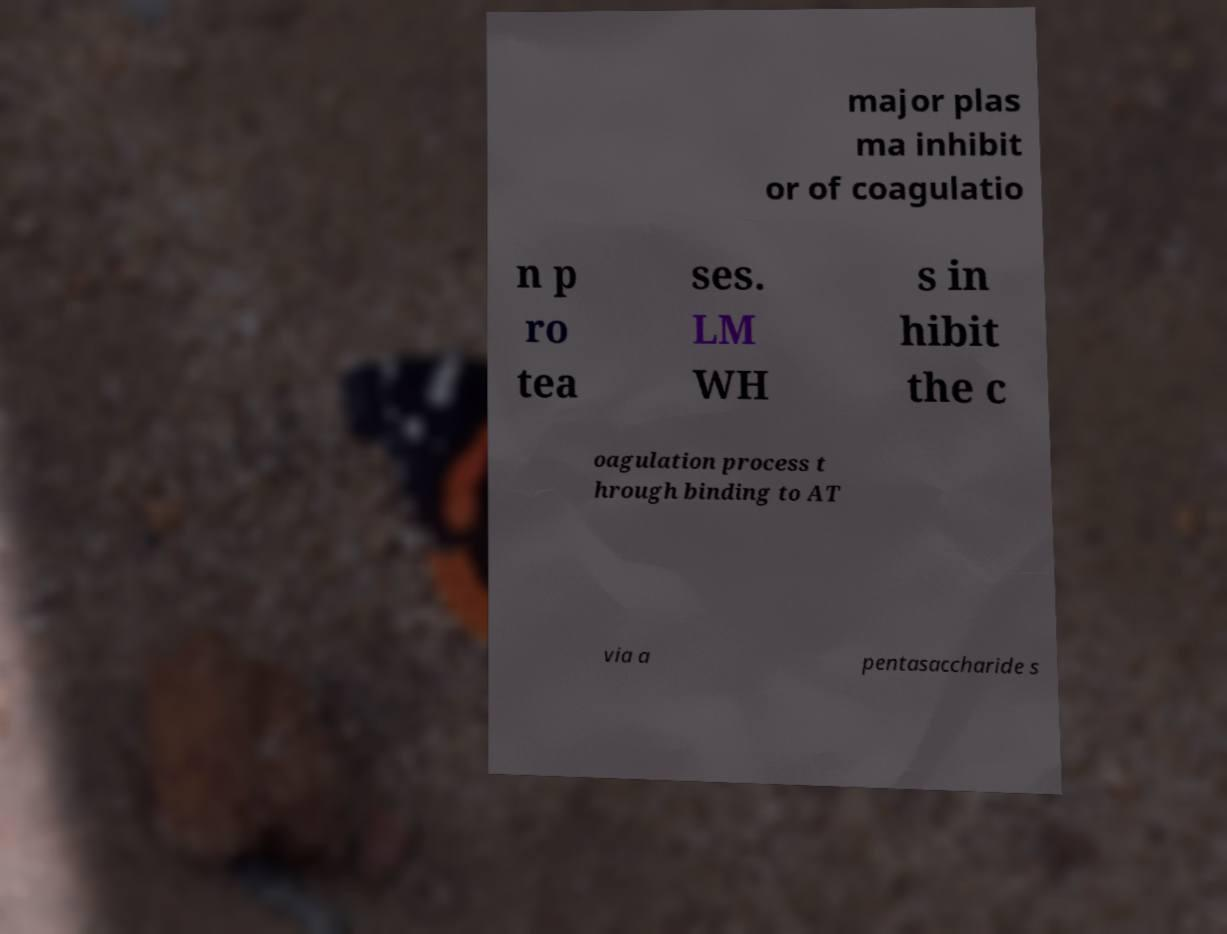For documentation purposes, I need the text within this image transcribed. Could you provide that? major plas ma inhibit or of coagulatio n p ro tea ses. LM WH s in hibit the c oagulation process t hrough binding to AT via a pentasaccharide s 